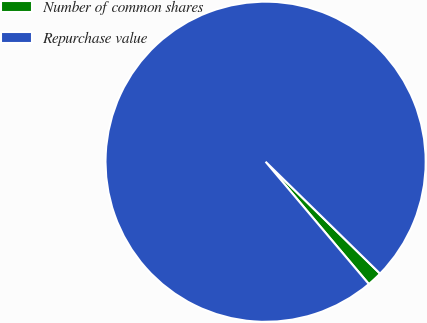Convert chart. <chart><loc_0><loc_0><loc_500><loc_500><pie_chart><fcel>Number of common shares<fcel>Repurchase value<nl><fcel>1.52%<fcel>98.48%<nl></chart> 